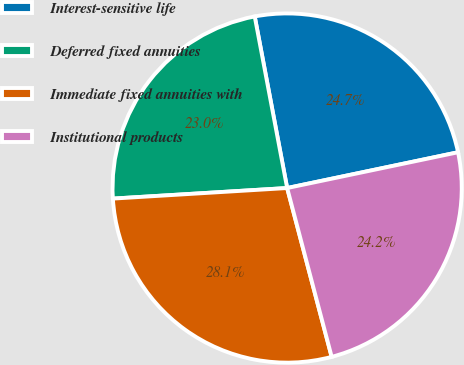Convert chart to OTSL. <chart><loc_0><loc_0><loc_500><loc_500><pie_chart><fcel>Interest-sensitive life<fcel>Deferred fixed annuities<fcel>Immediate fixed annuities with<fcel>Institutional products<nl><fcel>24.69%<fcel>22.99%<fcel>28.14%<fcel>24.18%<nl></chart> 